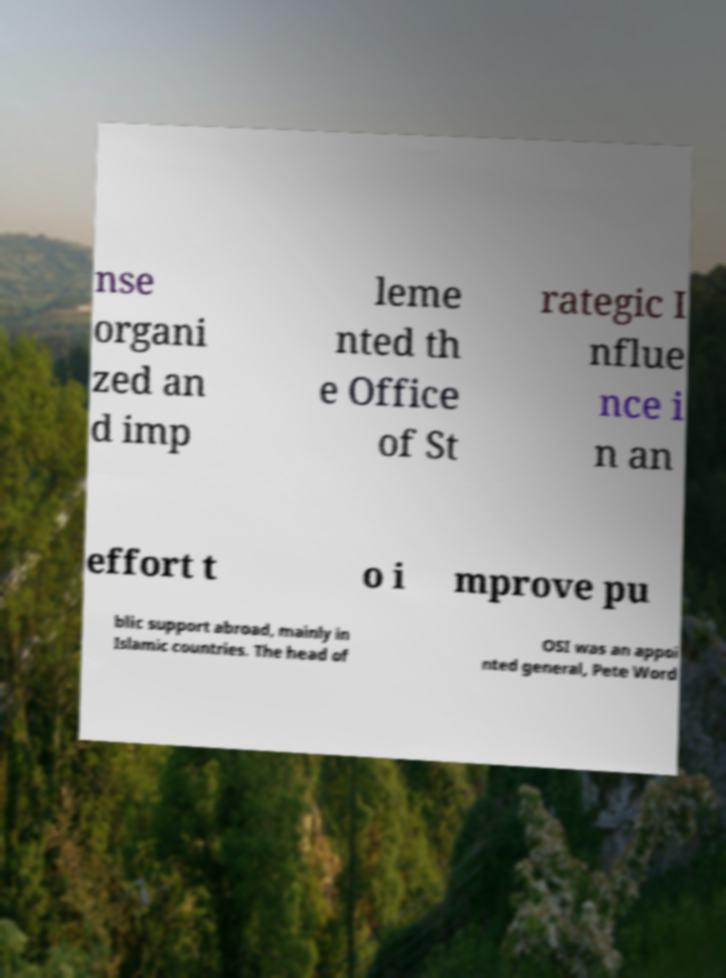Can you accurately transcribe the text from the provided image for me? nse organi zed an d imp leme nted th e Office of St rategic I nflue nce i n an effort t o i mprove pu blic support abroad, mainly in Islamic countries. The head of OSI was an appoi nted general, Pete Word 